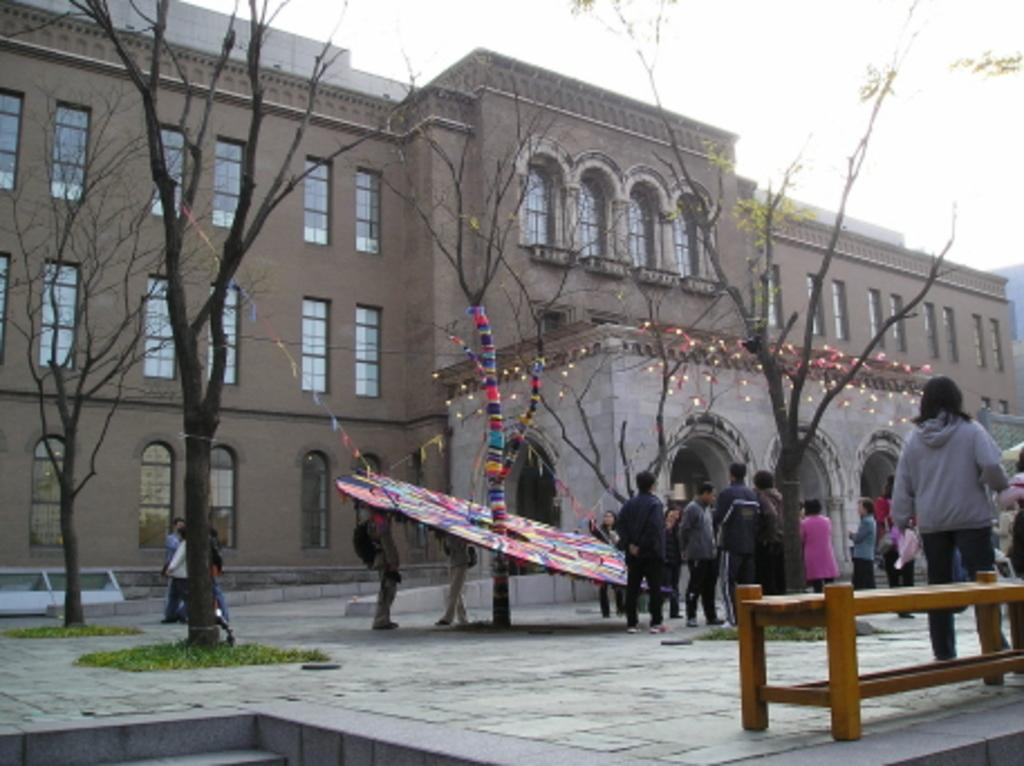What type of structure is visible in the image? There is a building in the image. What can be seen in front of the building? There are trees in front of the building. What are the people in the image doing? There is a group of people standing on the ground. What type of seating is available in the image? There is a bench in the image. What type of fish can be seen swimming in the fountain in the image? There is no fountain or fish present in the image. Who is the manager of the group of people in the image? There is no indication of a manager or hierarchy among the group of people in the image. 